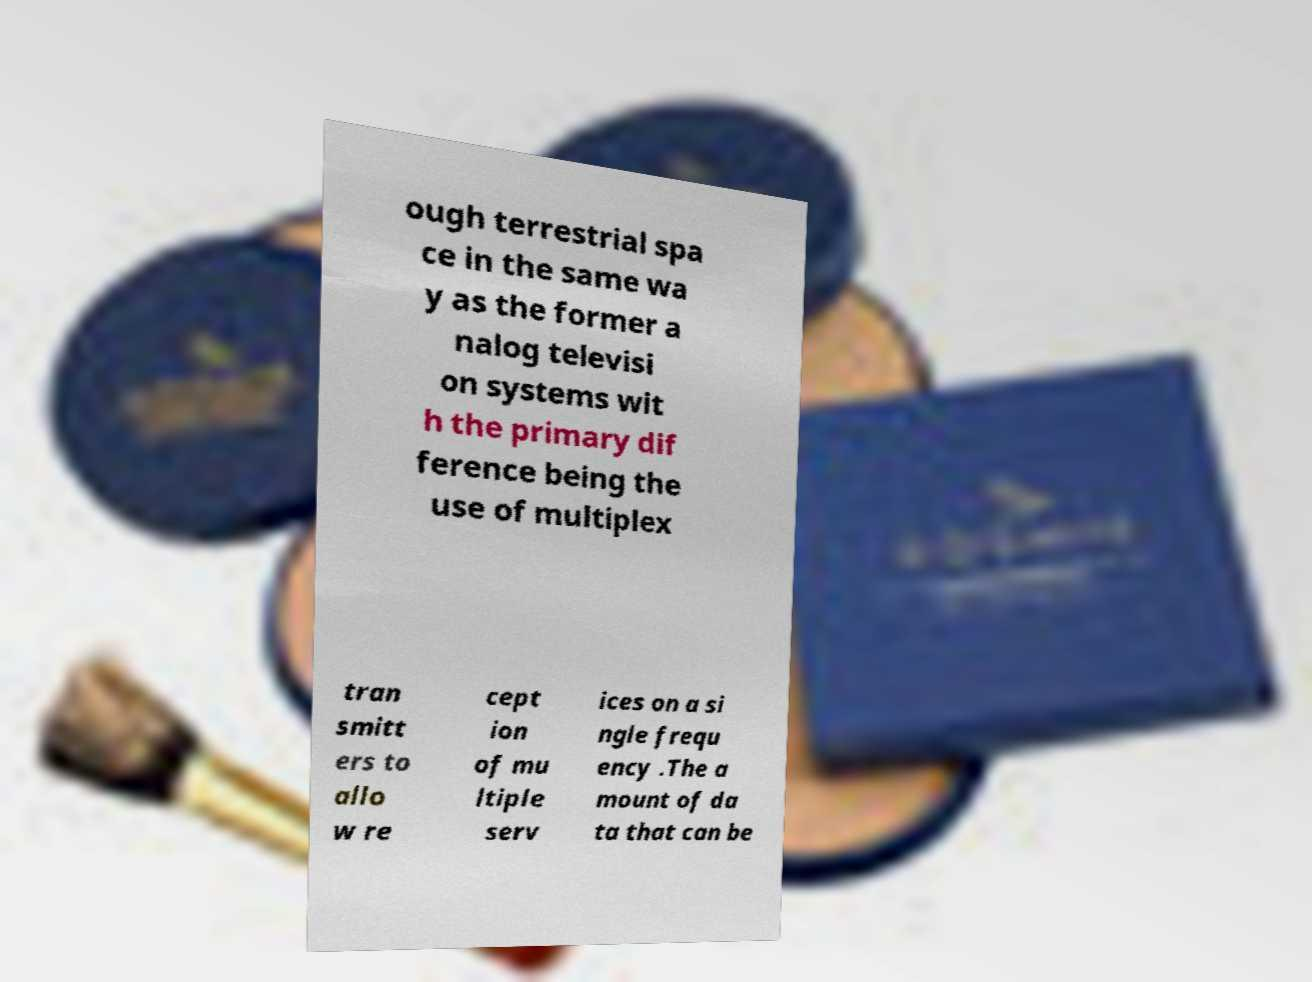What messages or text are displayed in this image? I need them in a readable, typed format. ough terrestrial spa ce in the same wa y as the former a nalog televisi on systems wit h the primary dif ference being the use of multiplex tran smitt ers to allo w re cept ion of mu ltiple serv ices on a si ngle frequ ency .The a mount of da ta that can be 